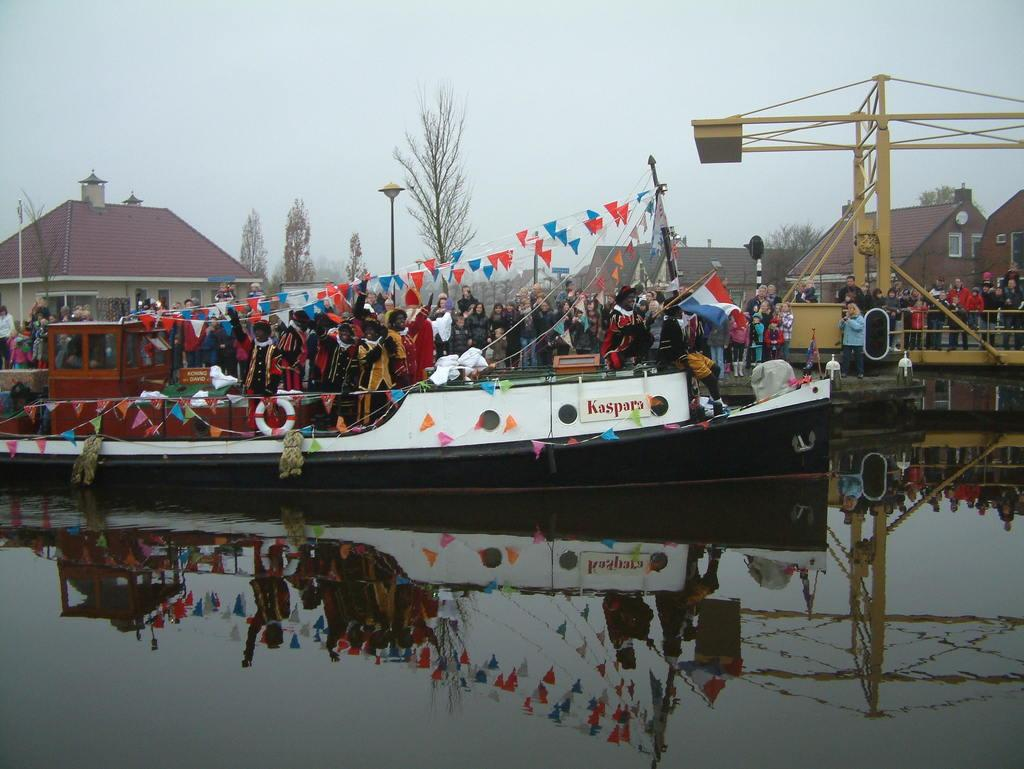What are the people in the image doing? The people in the image are standing in a boat. What can be seen in the background of the image? There are houses visible in the image. What type of vegetation is present in the image? There are trees in the image. What is the primary setting of the image? The primary setting of the image is water, as the people are in a boat. What is visible in the sky in the image? The sky is visible in the image. What type of net can be seen in the image? There is no net present in the image. What is the purpose of the needle in the image? There is no needle present in the image. 